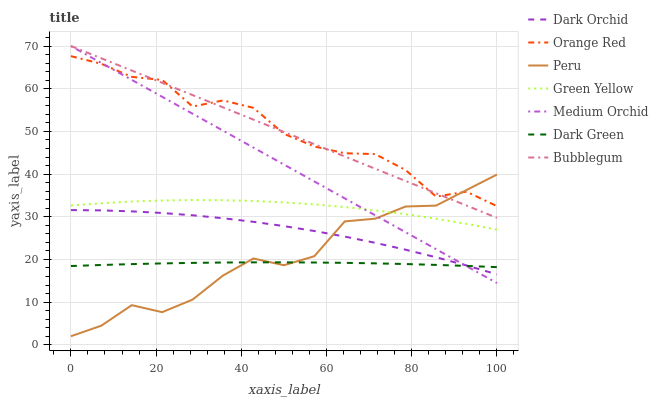Does Dark Green have the minimum area under the curve?
Answer yes or no. Yes. Does Orange Red have the maximum area under the curve?
Answer yes or no. Yes. Does Dark Orchid have the minimum area under the curve?
Answer yes or no. No. Does Dark Orchid have the maximum area under the curve?
Answer yes or no. No. Is Medium Orchid the smoothest?
Answer yes or no. Yes. Is Peru the roughest?
Answer yes or no. Yes. Is Dark Orchid the smoothest?
Answer yes or no. No. Is Dark Orchid the roughest?
Answer yes or no. No. Does Peru have the lowest value?
Answer yes or no. Yes. Does Dark Orchid have the lowest value?
Answer yes or no. No. Does Bubblegum have the highest value?
Answer yes or no. Yes. Does Dark Orchid have the highest value?
Answer yes or no. No. Is Dark Green less than Orange Red?
Answer yes or no. Yes. Is Green Yellow greater than Dark Green?
Answer yes or no. Yes. Does Medium Orchid intersect Dark Green?
Answer yes or no. Yes. Is Medium Orchid less than Dark Green?
Answer yes or no. No. Is Medium Orchid greater than Dark Green?
Answer yes or no. No. Does Dark Green intersect Orange Red?
Answer yes or no. No. 